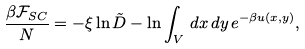Convert formula to latex. <formula><loc_0><loc_0><loc_500><loc_500>\frac { \beta { \mathcal { F } } _ { S C } } { N } = - \xi \ln \tilde { D } - \ln \int _ { V } \, { d } x \, { d } y \, e ^ { - \beta u ( x , y ) } ,</formula> 